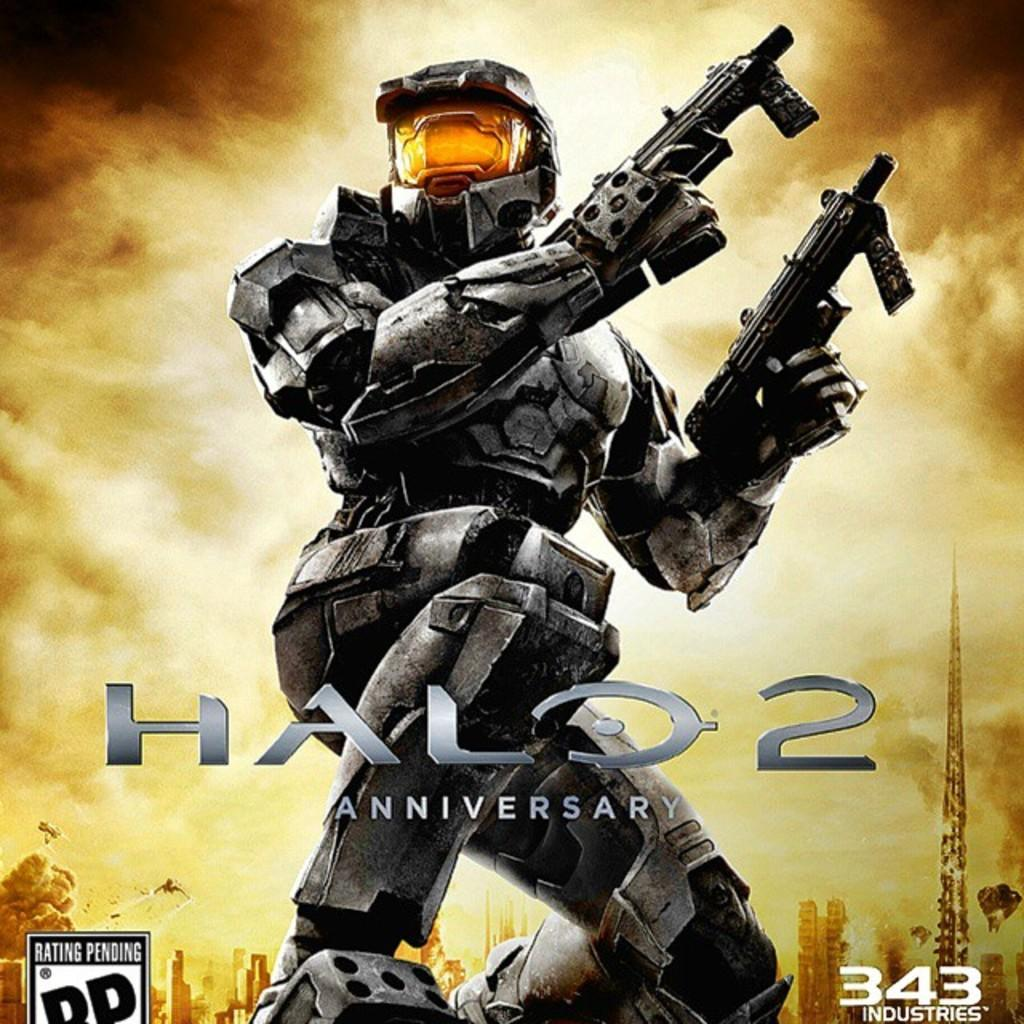<image>
Relay a brief, clear account of the picture shown. The Halo 2 video game cover rated RP. 